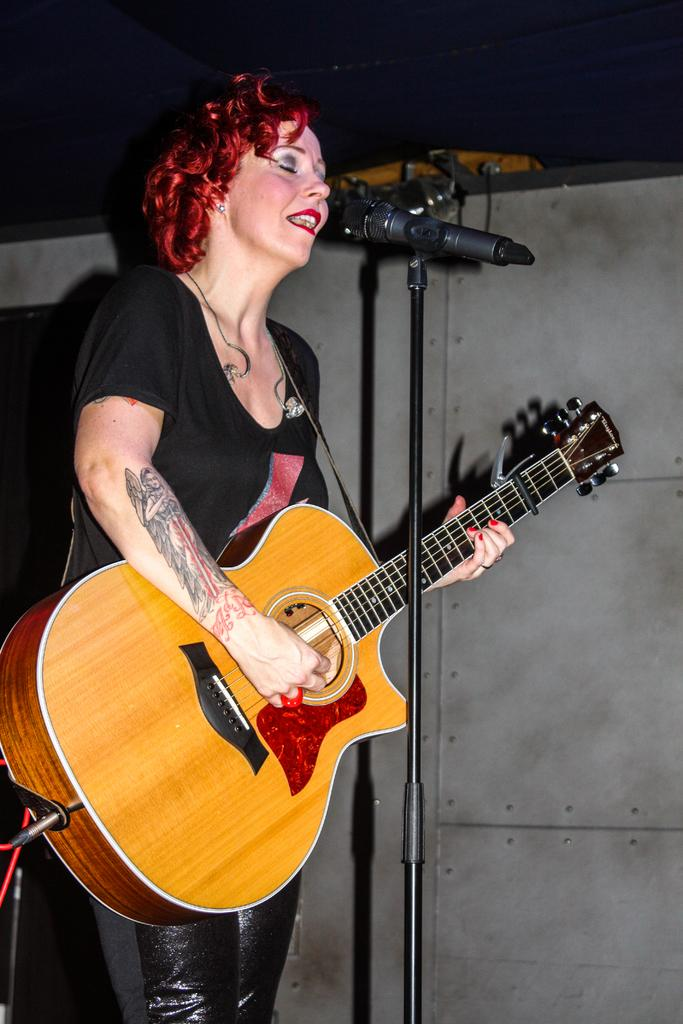Who is the main subject in the image? There is a woman in the image. What is the woman wearing? The woman is wearing a black t-shirt. What object is the woman holding in the image? The woman is holding a guitar. What other musical equipment can be seen in the image? There is a microphone and a microphone stand in the image. How many buttons can be seen on the woman's t-shirt in the image? There is no information about buttons on the woman's t-shirt in the image. What time is displayed on the clock in the image? There is no clock present in the image. 